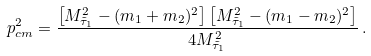Convert formula to latex. <formula><loc_0><loc_0><loc_500><loc_500>p _ { c m } ^ { 2 } = \frac { \left [ M ^ { 2 } _ { \tilde { \tau } _ { 1 } } - ( m _ { 1 } + m _ { 2 } ) ^ { 2 } \right ] \left [ M ^ { 2 } _ { \tilde { \tau } _ { 1 } } - ( m _ { 1 } - m _ { 2 } ) ^ { 2 } \right ] } { 4 M _ { \tilde { \tau } _ { 1 } } ^ { 2 } } \, .</formula> 